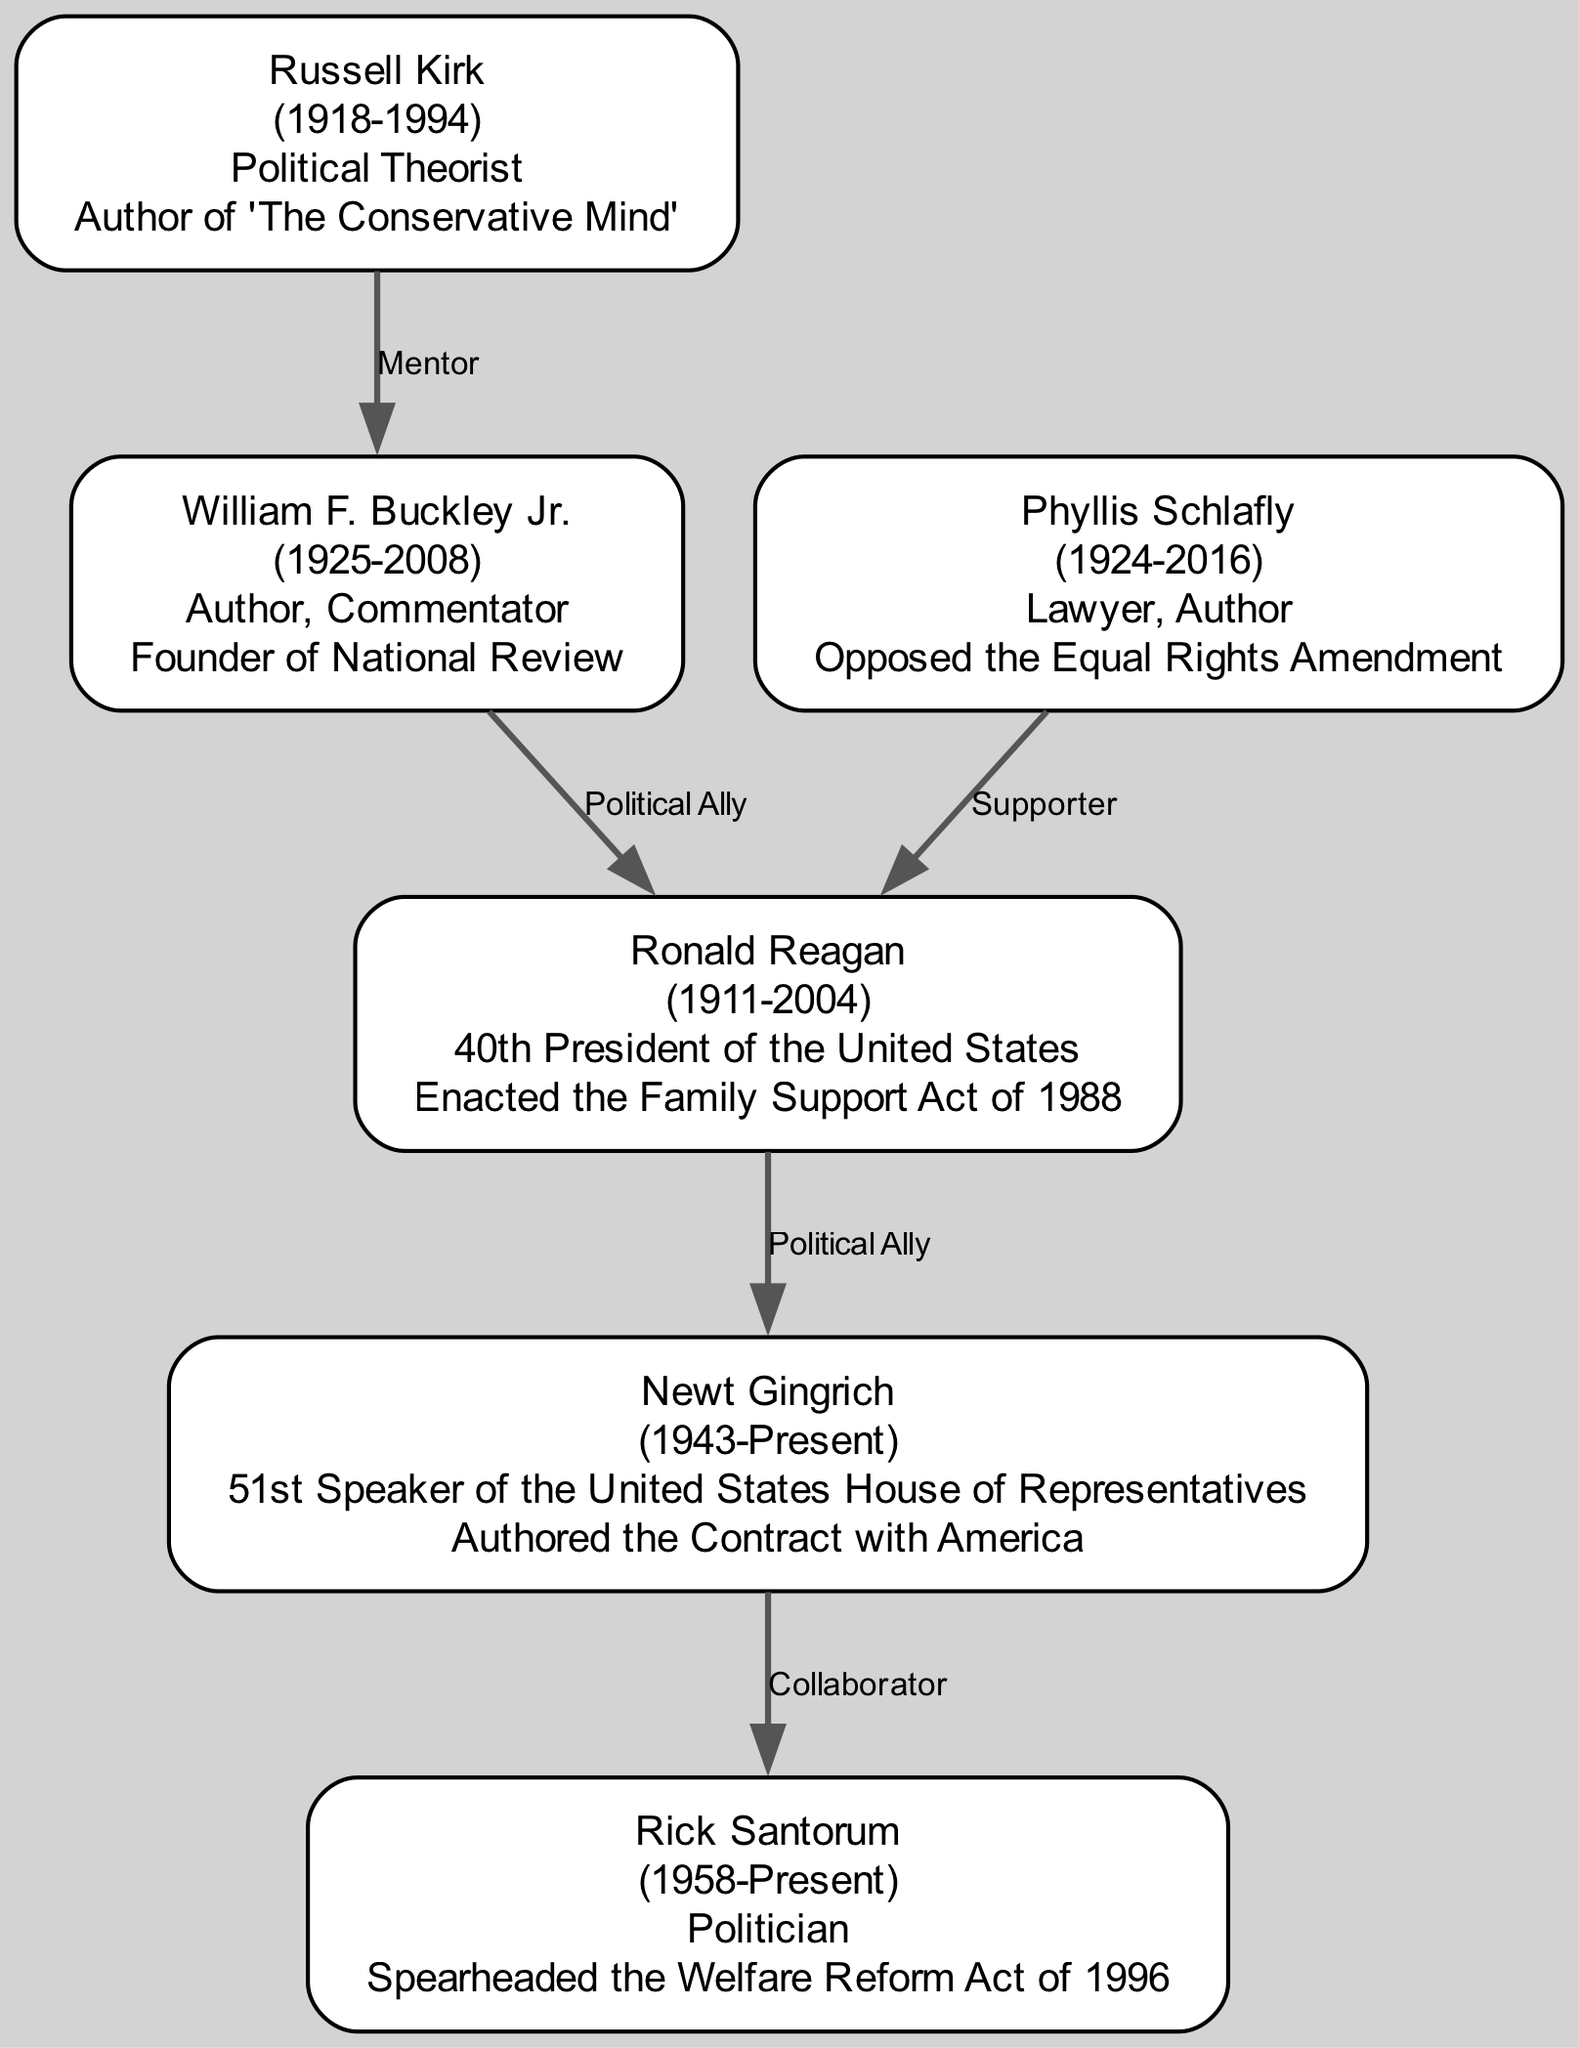What is the profession of Russell Kirk? The diagram lists Russell Kirk's profession as "Political Theorist", which is provided in his node information.
Answer: Political Theorist Who is considered a mentor to William F. Buckley Jr.? The diagram indicates that Russell Kirk has the relationship of "Mentor" with William F. Buckley Jr., as shown in the connection between their nodes.
Answer: Russell Kirk How many nodes are present in the diagram? By counting the nodes listed in the data, there are 6 nodes in total representing different advocates.
Answer: 6 What notable achievement is associated with Ronald Reagan? The diagram highlights that Ronald Reagan is known for enacting the "Family Support Act of 1988," which is noted in his node details.
Answer: Enacted the Family Support Act of 1988 What type of relationship exists between Newt Gingrich and Rick Santorum? The diagram specifies that Newt Gingrich and Rick Santorum have the relationship labeled "Collaborator," which is defined in their connection.
Answer: Collaborator How many edges connect the nodes in the diagram? The connections provided show that there are 5 edges linking the nodes, indicating the relationships among the advocates.
Answer: 5 Who authored the "Contract with America"? According to the node information, Newt Gingrich is identified as the author of the "Contract with America."
Answer: Newt Gingrich Which advocate opposed the Equal Rights Amendment? The diagram specifies that Phyllis Schlafly opposed the Equal Rights Amendment, which is reflected in her notable achievements.
Answer: Phyllis Schlafly Name a political ally of Ronald Reagan. The diagram indicates William F. Buckley Jr. has a relationship defined as "Political Ally" with Ronald Reagan.
Answer: William F. Buckley Jr 